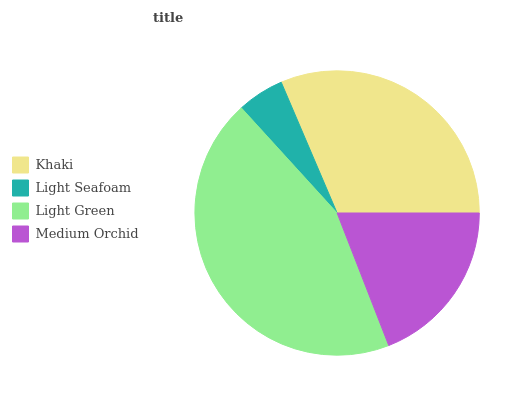Is Light Seafoam the minimum?
Answer yes or no. Yes. Is Light Green the maximum?
Answer yes or no. Yes. Is Light Green the minimum?
Answer yes or no. No. Is Light Seafoam the maximum?
Answer yes or no. No. Is Light Green greater than Light Seafoam?
Answer yes or no. Yes. Is Light Seafoam less than Light Green?
Answer yes or no. Yes. Is Light Seafoam greater than Light Green?
Answer yes or no. No. Is Light Green less than Light Seafoam?
Answer yes or no. No. Is Khaki the high median?
Answer yes or no. Yes. Is Medium Orchid the low median?
Answer yes or no. Yes. Is Light Green the high median?
Answer yes or no. No. Is Light Green the low median?
Answer yes or no. No. 